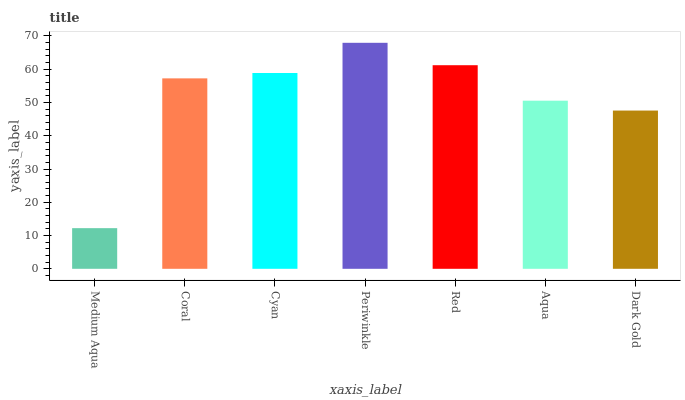Is Medium Aqua the minimum?
Answer yes or no. Yes. Is Periwinkle the maximum?
Answer yes or no. Yes. Is Coral the minimum?
Answer yes or no. No. Is Coral the maximum?
Answer yes or no. No. Is Coral greater than Medium Aqua?
Answer yes or no. Yes. Is Medium Aqua less than Coral?
Answer yes or no. Yes. Is Medium Aqua greater than Coral?
Answer yes or no. No. Is Coral less than Medium Aqua?
Answer yes or no. No. Is Coral the high median?
Answer yes or no. Yes. Is Coral the low median?
Answer yes or no. Yes. Is Medium Aqua the high median?
Answer yes or no. No. Is Dark Gold the low median?
Answer yes or no. No. 